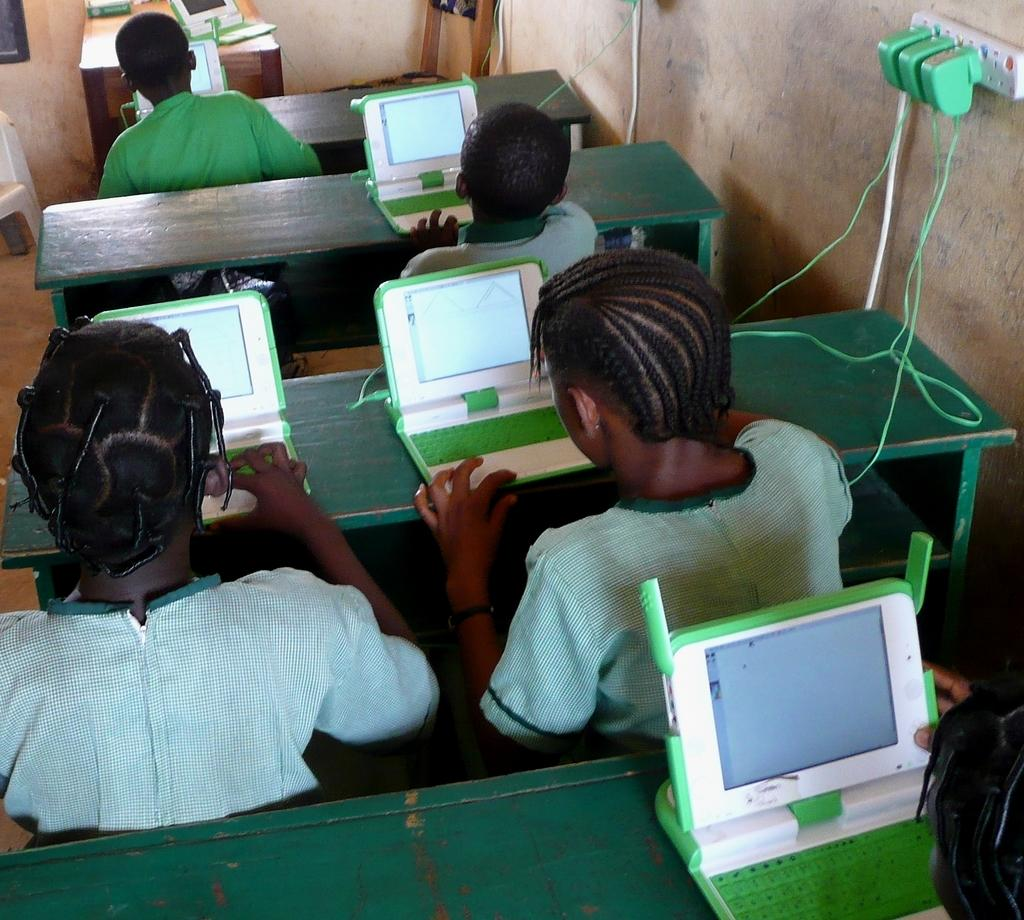What are the persons in the image doing? The persons in the image are using laptops. Where are the laptops located in the image? The laptops are at the center of the image. What else can be seen on the right side of the image? There is an electric board on the right side of the image. What type of trousers are the persons wearing in the image? There is no information about the trousers the persons are wearing in the image. 